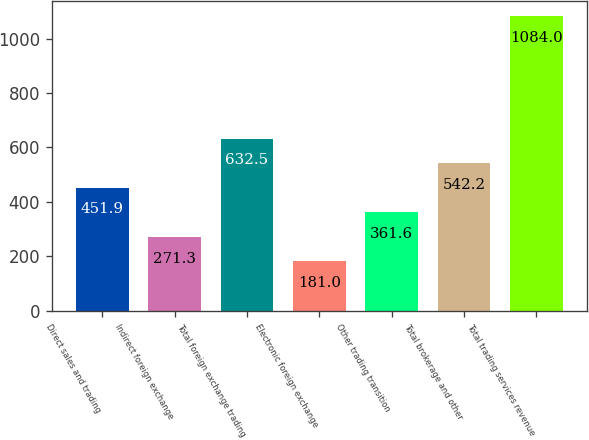<chart> <loc_0><loc_0><loc_500><loc_500><bar_chart><fcel>Direct sales and trading<fcel>Indirect foreign exchange<fcel>Total foreign exchange trading<fcel>Electronic foreign exchange<fcel>Other trading transition<fcel>Total brokerage and other<fcel>Total trading services revenue<nl><fcel>451.9<fcel>271.3<fcel>632.5<fcel>181<fcel>361.6<fcel>542.2<fcel>1084<nl></chart> 